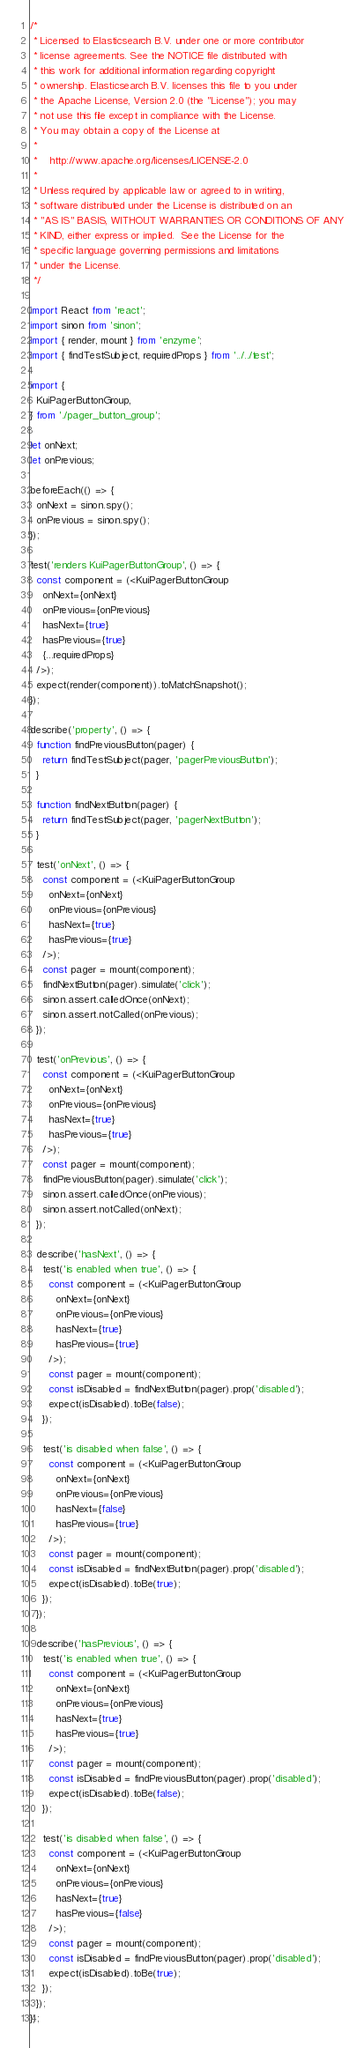Convert code to text. <code><loc_0><loc_0><loc_500><loc_500><_JavaScript_>/*
 * Licensed to Elasticsearch B.V. under one or more contributor
 * license agreements. See the NOTICE file distributed with
 * this work for additional information regarding copyright
 * ownership. Elasticsearch B.V. licenses this file to you under
 * the Apache License, Version 2.0 (the "License"); you may
 * not use this file except in compliance with the License.
 * You may obtain a copy of the License at
 *
 *    http://www.apache.org/licenses/LICENSE-2.0
 *
 * Unless required by applicable law or agreed to in writing,
 * software distributed under the License is distributed on an
 * "AS IS" BASIS, WITHOUT WARRANTIES OR CONDITIONS OF ANY
 * KIND, either express or implied.  See the License for the
 * specific language governing permissions and limitations
 * under the License.
 */

import React from 'react';
import sinon from 'sinon';
import { render, mount } from 'enzyme';
import { findTestSubject, requiredProps } from '../../test';

import {
  KuiPagerButtonGroup,
} from './pager_button_group';

let onNext;
let onPrevious;

beforeEach(() => {
  onNext = sinon.spy();
  onPrevious = sinon.spy();
});

test('renders KuiPagerButtonGroup', () => {
  const component = (<KuiPagerButtonGroup
    onNext={onNext}
    onPrevious={onPrevious}
    hasNext={true}
    hasPrevious={true}
    {...requiredProps}
  />);
  expect(render(component)).toMatchSnapshot();
});

describe('property', () => {
  function findPreviousButton(pager) {
    return findTestSubject(pager, 'pagerPreviousButton');
  }

  function findNextButton(pager) {
    return findTestSubject(pager, 'pagerNextButton');
  }

  test('onNext', () => {
    const component = (<KuiPagerButtonGroup
      onNext={onNext}
      onPrevious={onPrevious}
      hasNext={true}
      hasPrevious={true}
    />);
    const pager = mount(component);
    findNextButton(pager).simulate('click');
    sinon.assert.calledOnce(onNext);
    sinon.assert.notCalled(onPrevious);
  });

  test('onPrevious', () => {
    const component = (<KuiPagerButtonGroup
      onNext={onNext}
      onPrevious={onPrevious}
      hasNext={true}
      hasPrevious={true}
    />);
    const pager = mount(component);
    findPreviousButton(pager).simulate('click');
    sinon.assert.calledOnce(onPrevious);
    sinon.assert.notCalled(onNext);
  });

  describe('hasNext', () => {
    test('is enabled when true', () => {
      const component = (<KuiPagerButtonGroup
        onNext={onNext}
        onPrevious={onPrevious}
        hasNext={true}
        hasPrevious={true}
      />);
      const pager = mount(component);
      const isDisabled = findNextButton(pager).prop('disabled');
      expect(isDisabled).toBe(false);
    });

    test('is disabled when false', () => {
      const component = (<KuiPagerButtonGroup
        onNext={onNext}
        onPrevious={onPrevious}
        hasNext={false}
        hasPrevious={true}
      />);
      const pager = mount(component);
      const isDisabled = findNextButton(pager).prop('disabled');
      expect(isDisabled).toBe(true);
    });
  });

  describe('hasPrevious', () => {
    test('is enabled when true', () => {
      const component = (<KuiPagerButtonGroup
        onNext={onNext}
        onPrevious={onPrevious}
        hasNext={true}
        hasPrevious={true}
      />);
      const pager = mount(component);
      const isDisabled = findPreviousButton(pager).prop('disabled');
      expect(isDisabled).toBe(false);
    });

    test('is disabled when false', () => {
      const component = (<KuiPagerButtonGroup
        onNext={onNext}
        onPrevious={onPrevious}
        hasNext={true}
        hasPrevious={false}
      />);
      const pager = mount(component);
      const isDisabled = findPreviousButton(pager).prop('disabled');
      expect(isDisabled).toBe(true);
    });
  });
});
</code> 